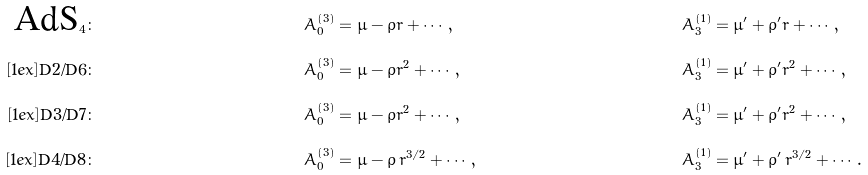<formula> <loc_0><loc_0><loc_500><loc_500>\text {AdS} _ { 4 } \colon & \quad & A _ { 0 } ^ { ( 3 ) } & = \mu - \rho r + \cdots \, , \quad & A _ { 3 } ^ { ( 1 ) } & = \mu ^ { \prime } + \rho ^ { \prime } r + \cdots \, , \\ [ 1 e x ] \text {D2/D6} \colon & \quad & A _ { 0 } ^ { ( 3 ) } & = \mu - \rho r ^ { 2 } + \cdots \, , \quad & A _ { 3 } ^ { ( 1 ) } & = \mu ^ { \prime } + \rho ^ { \prime } r ^ { 2 } + \cdots \, , \\ [ 1 e x ] \text {D3/D7} \colon & \quad & A _ { 0 } ^ { ( 3 ) } & = \mu - \rho r ^ { 2 } + \cdots \, , \quad & A _ { 3 } ^ { ( 1 ) } & = \mu ^ { \prime } + \rho ^ { \prime } r ^ { 2 } + \cdots \, , \\ [ 1 e x ] \text {D4/D8} \colon & \quad & A _ { 0 } ^ { ( 3 ) } & = \mu - \rho \, r ^ { 3 / 2 } + \cdots \, , \quad & A _ { 3 } ^ { ( 1 ) } & = \mu ^ { \prime } + \rho ^ { \prime } \, r ^ { 3 / 2 } + \cdots \, .</formula> 